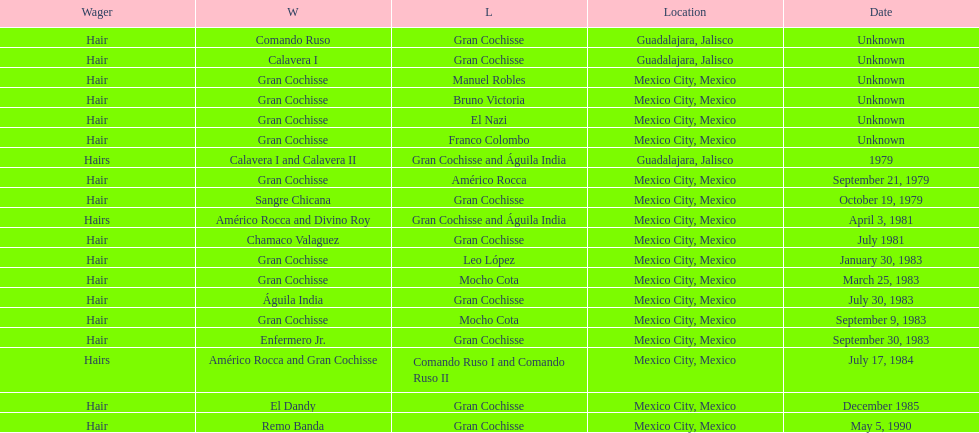How many games more than chamaco valaguez did sangre chicana win? 0. 